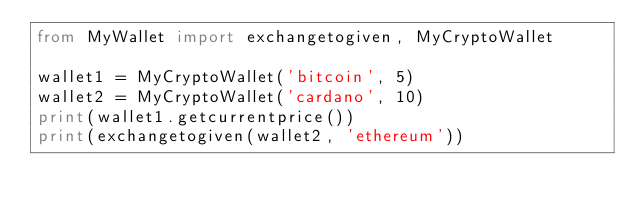Convert code to text. <code><loc_0><loc_0><loc_500><loc_500><_Python_>from MyWallet import exchangetogiven, MyCryptoWallet

wallet1 = MyCryptoWallet('bitcoin', 5)
wallet2 = MyCryptoWallet('cardano', 10)
print(wallet1.getcurrentprice())
print(exchangetogiven(wallet2, 'ethereum'))
</code> 